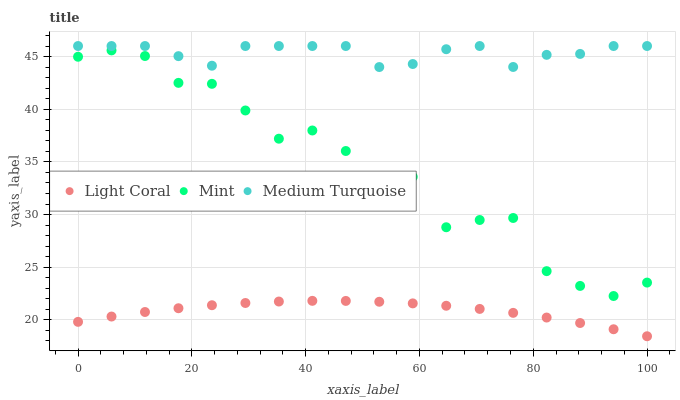Does Light Coral have the minimum area under the curve?
Answer yes or no. Yes. Does Medium Turquoise have the maximum area under the curve?
Answer yes or no. Yes. Does Mint have the minimum area under the curve?
Answer yes or no. No. Does Mint have the maximum area under the curve?
Answer yes or no. No. Is Light Coral the smoothest?
Answer yes or no. Yes. Is Mint the roughest?
Answer yes or no. Yes. Is Medium Turquoise the smoothest?
Answer yes or no. No. Is Medium Turquoise the roughest?
Answer yes or no. No. Does Light Coral have the lowest value?
Answer yes or no. Yes. Does Mint have the lowest value?
Answer yes or no. No. Does Medium Turquoise have the highest value?
Answer yes or no. Yes. Does Mint have the highest value?
Answer yes or no. No. Is Light Coral less than Mint?
Answer yes or no. Yes. Is Medium Turquoise greater than Light Coral?
Answer yes or no. Yes. Does Light Coral intersect Mint?
Answer yes or no. No. 